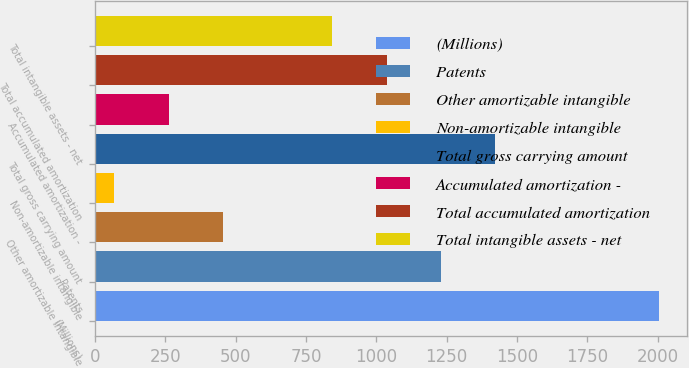Convert chart to OTSL. <chart><loc_0><loc_0><loc_500><loc_500><bar_chart><fcel>(Millions)<fcel>Patents<fcel>Other amortizable intangible<fcel>Non-amortizable intangible<fcel>Total gross carrying amount<fcel>Accumulated amortization -<fcel>Total accumulated amortization<fcel>Total intangible assets - net<nl><fcel>2004<fcel>1230<fcel>456<fcel>69<fcel>1423.5<fcel>262.5<fcel>1036.5<fcel>843<nl></chart> 